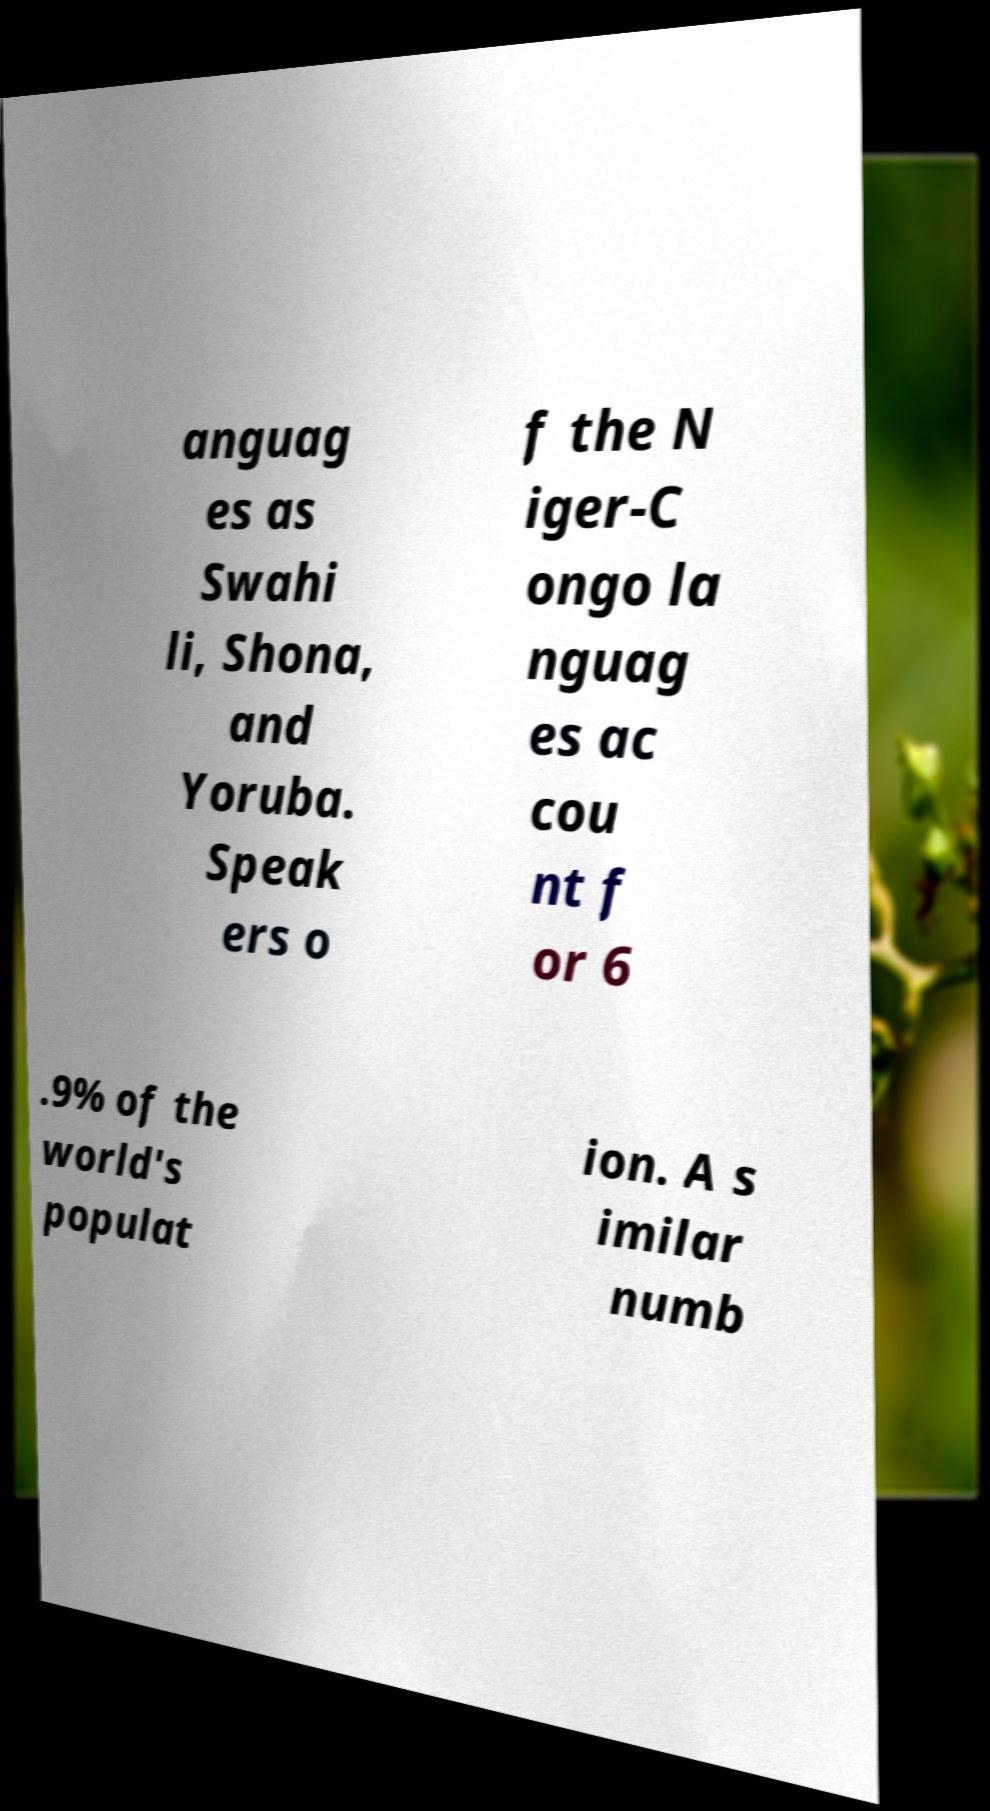Could you extract and type out the text from this image? anguag es as Swahi li, Shona, and Yoruba. Speak ers o f the N iger-C ongo la nguag es ac cou nt f or 6 .9% of the world's populat ion. A s imilar numb 